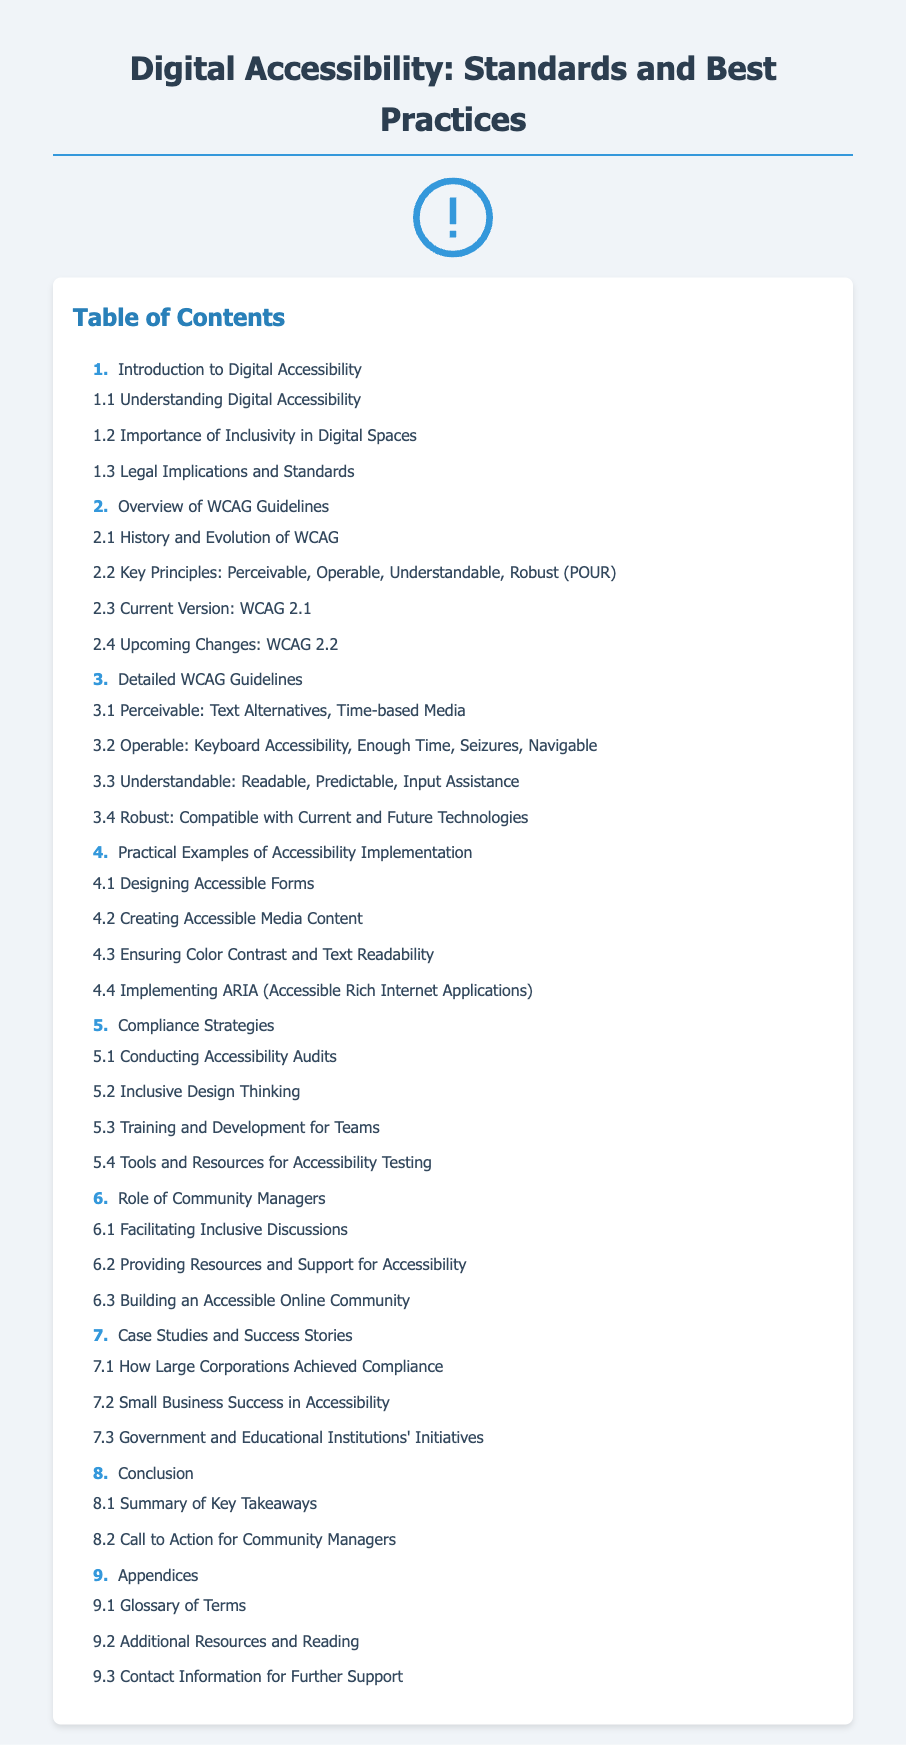What is the first section of the document? The first section of the Table of Contents is labeled as "1. Introduction to Digital Accessibility".
Answer: Introduction to Digital Accessibility How many principles are highlighted under the WCAG Guidelines? The document mentions four key principles under the WCAG Guidelines as part of the outline.
Answer: Four What is the current version of WCAG mentioned? The document specifically states the current version of WCAG is 2.1.
Answer: WCAG 2.1 Which section discusses the role of community managers? The document clearly designates the sixth section to discuss the role of community managers.
Answer: Role of Community Managers What section provides examples of accessibility implementation? The Table of Contents identifies the fourth section dedicated to practical examples of accessibility implementation.
Answer: Practical Examples of Accessibility Implementation What is the last topic mentioned in the appendices? The last topic in the appendices focuses on contact information for further support.
Answer: Contact Information for Further Support How many case studies are referenced? The document references three case studies under the case studies section.
Answer: Three What key concept is covered in section 3.2? Section 3.2 covers operable concepts such as keyboard accessibility and enough time.
Answer: Operable: Keyboard Accessibility, Enough Time, Seizures, Navigable What is the focus of section 7.3? Section 7.3 outlines initiatives by government and educational institutions regarding accessibility.
Answer: Government and Educational Institutions' Initiatives 